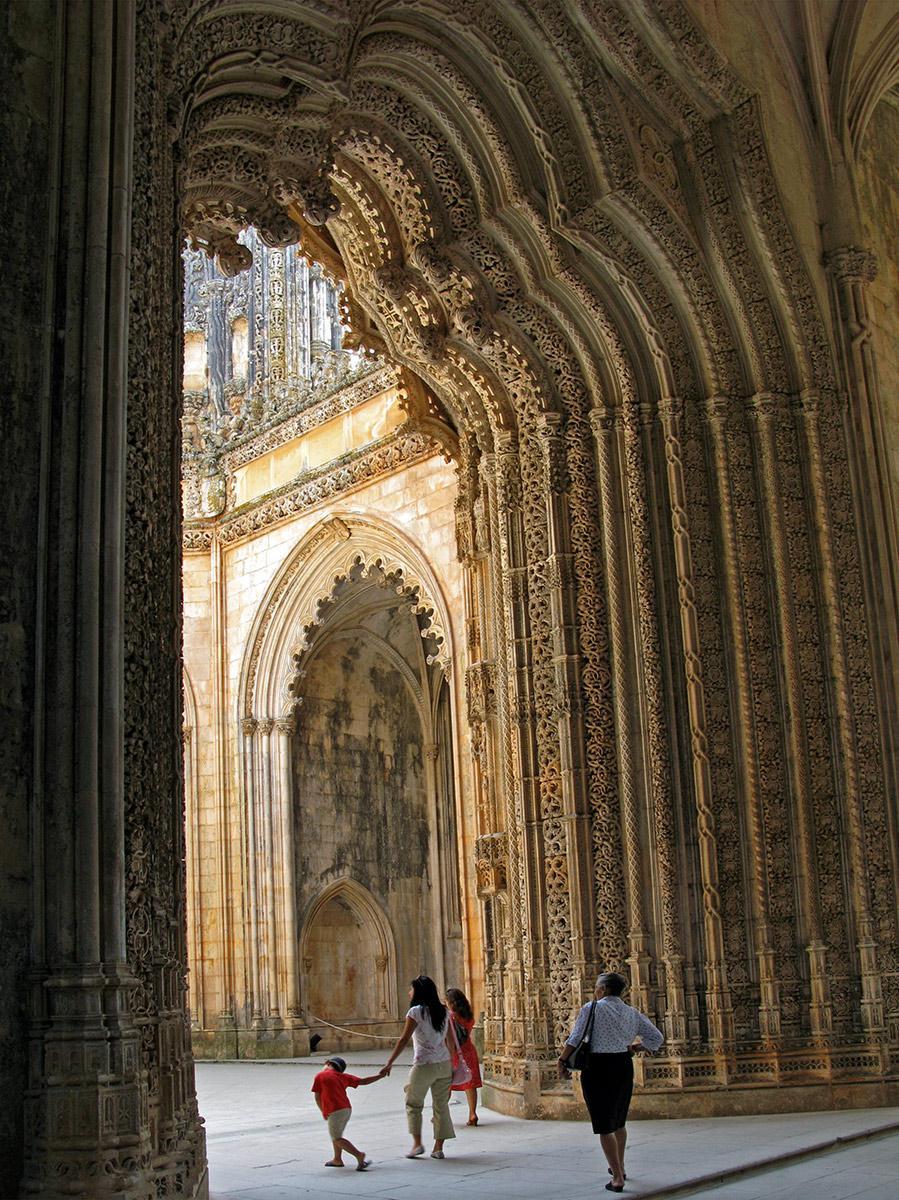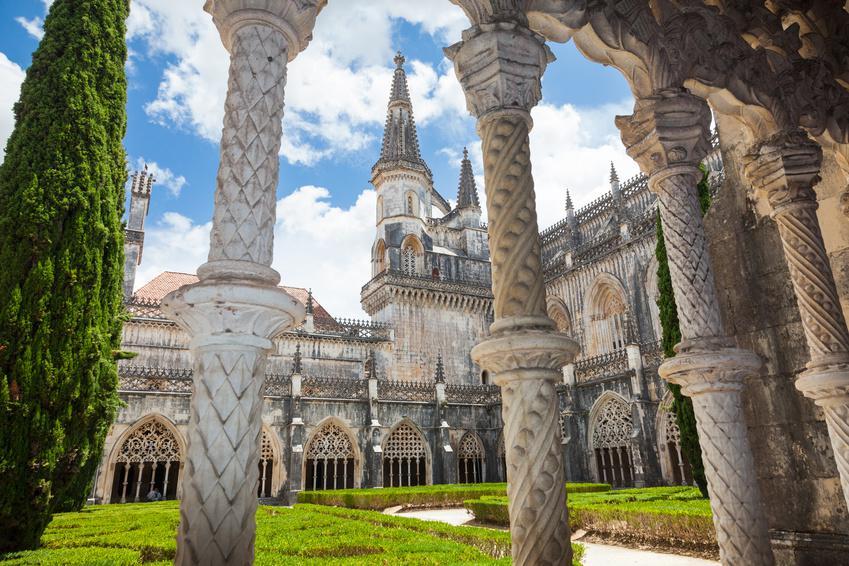The first image is the image on the left, the second image is the image on the right. Evaluate the accuracy of this statement regarding the images: "An image shows multiple people standing in front of a massive archway.". Is it true? Answer yes or no. Yes. The first image is the image on the left, the second image is the image on the right. Evaluate the accuracy of this statement regarding the images: "The image on the left doesn't show the turrets of the castle.". Is it true? Answer yes or no. Yes. 